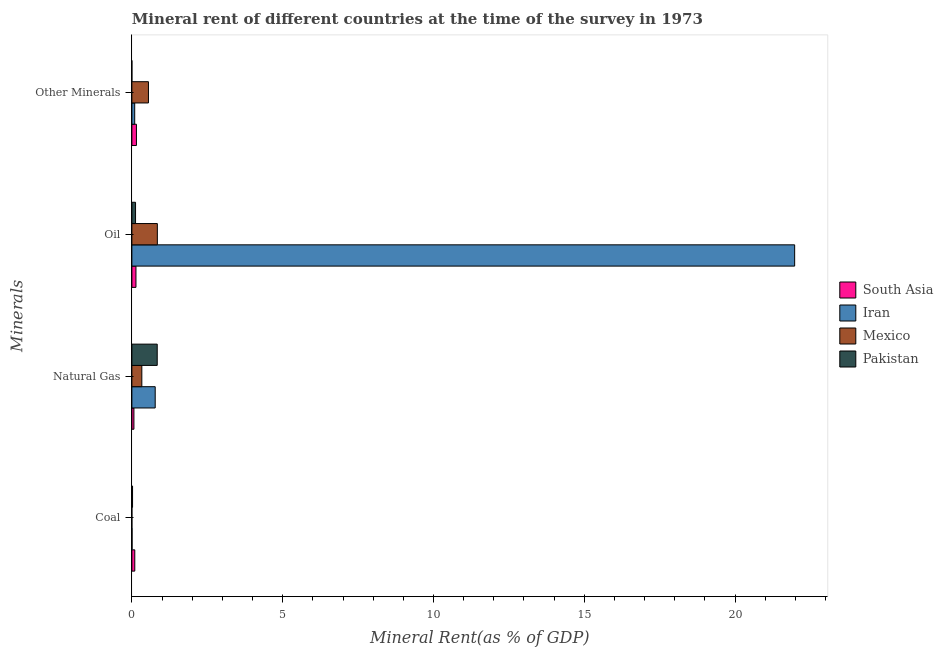How many groups of bars are there?
Your answer should be very brief. 4. Are the number of bars per tick equal to the number of legend labels?
Keep it short and to the point. Yes. Are the number of bars on each tick of the Y-axis equal?
Give a very brief answer. Yes. How many bars are there on the 2nd tick from the top?
Provide a succinct answer. 4. How many bars are there on the 2nd tick from the bottom?
Provide a succinct answer. 4. What is the label of the 4th group of bars from the top?
Provide a short and direct response. Coal. What is the oil rent in Mexico?
Offer a terse response. 0.84. Across all countries, what is the maximum  rent of other minerals?
Give a very brief answer. 0.55. Across all countries, what is the minimum  rent of other minerals?
Your response must be concise. 1.39988416425869e-5. In which country was the coal rent maximum?
Offer a terse response. South Asia. What is the total coal rent in the graph?
Provide a succinct answer. 0.13. What is the difference between the  rent of other minerals in Pakistan and that in Mexico?
Offer a very short reply. -0.55. What is the difference between the coal rent in Pakistan and the oil rent in Iran?
Give a very brief answer. -21.95. What is the average natural gas rent per country?
Keep it short and to the point. 0.5. What is the difference between the oil rent and  rent of other minerals in Mexico?
Keep it short and to the point. 0.3. In how many countries, is the  rent of other minerals greater than 21 %?
Offer a terse response. 0. What is the ratio of the oil rent in Iran to that in Pakistan?
Keep it short and to the point. 180.61. Is the difference between the natural gas rent in South Asia and Pakistan greater than the difference between the coal rent in South Asia and Pakistan?
Your response must be concise. No. What is the difference between the highest and the second highest  rent of other minerals?
Give a very brief answer. 0.4. What is the difference between the highest and the lowest  rent of other minerals?
Give a very brief answer. 0.55. In how many countries, is the natural gas rent greater than the average natural gas rent taken over all countries?
Your answer should be very brief. 2. Is it the case that in every country, the sum of the coal rent and oil rent is greater than the sum of natural gas rent and  rent of other minerals?
Your answer should be very brief. Yes. What does the 2nd bar from the top in Coal represents?
Provide a short and direct response. Mexico. What does the 1st bar from the bottom in Natural Gas represents?
Your response must be concise. South Asia. Is it the case that in every country, the sum of the coal rent and natural gas rent is greater than the oil rent?
Keep it short and to the point. No. How many bars are there?
Your answer should be very brief. 16. Are all the bars in the graph horizontal?
Your response must be concise. Yes. Are the values on the major ticks of X-axis written in scientific E-notation?
Keep it short and to the point. No. Where does the legend appear in the graph?
Your answer should be compact. Center right. How are the legend labels stacked?
Provide a succinct answer. Vertical. What is the title of the graph?
Keep it short and to the point. Mineral rent of different countries at the time of the survey in 1973. Does "Mozambique" appear as one of the legend labels in the graph?
Give a very brief answer. No. What is the label or title of the X-axis?
Keep it short and to the point. Mineral Rent(as % of GDP). What is the label or title of the Y-axis?
Keep it short and to the point. Minerals. What is the Mineral Rent(as % of GDP) of South Asia in Coal?
Make the answer very short. 0.1. What is the Mineral Rent(as % of GDP) of Iran in Coal?
Offer a very short reply. 0.01. What is the Mineral Rent(as % of GDP) of Mexico in Coal?
Keep it short and to the point. 9.86259771572145e-5. What is the Mineral Rent(as % of GDP) of Pakistan in Coal?
Give a very brief answer. 0.02. What is the Mineral Rent(as % of GDP) of South Asia in Natural Gas?
Offer a terse response. 0.07. What is the Mineral Rent(as % of GDP) of Iran in Natural Gas?
Offer a very short reply. 0.77. What is the Mineral Rent(as % of GDP) of Mexico in Natural Gas?
Your answer should be compact. 0.33. What is the Mineral Rent(as % of GDP) of Pakistan in Natural Gas?
Offer a terse response. 0.84. What is the Mineral Rent(as % of GDP) in South Asia in Oil?
Ensure brevity in your answer.  0.14. What is the Mineral Rent(as % of GDP) in Iran in Oil?
Offer a very short reply. 21.98. What is the Mineral Rent(as % of GDP) of Mexico in Oil?
Your answer should be very brief. 0.84. What is the Mineral Rent(as % of GDP) of Pakistan in Oil?
Provide a short and direct response. 0.12. What is the Mineral Rent(as % of GDP) of South Asia in Other Minerals?
Make the answer very short. 0.15. What is the Mineral Rent(as % of GDP) of Iran in Other Minerals?
Ensure brevity in your answer.  0.09. What is the Mineral Rent(as % of GDP) in Mexico in Other Minerals?
Your answer should be compact. 0.55. What is the Mineral Rent(as % of GDP) in Pakistan in Other Minerals?
Give a very brief answer. 1.39988416425869e-5. Across all Minerals, what is the maximum Mineral Rent(as % of GDP) in South Asia?
Offer a terse response. 0.15. Across all Minerals, what is the maximum Mineral Rent(as % of GDP) in Iran?
Ensure brevity in your answer.  21.98. Across all Minerals, what is the maximum Mineral Rent(as % of GDP) of Mexico?
Offer a very short reply. 0.84. Across all Minerals, what is the maximum Mineral Rent(as % of GDP) in Pakistan?
Provide a succinct answer. 0.84. Across all Minerals, what is the minimum Mineral Rent(as % of GDP) in South Asia?
Provide a short and direct response. 0.07. Across all Minerals, what is the minimum Mineral Rent(as % of GDP) of Iran?
Your answer should be very brief. 0.01. Across all Minerals, what is the minimum Mineral Rent(as % of GDP) of Mexico?
Your answer should be very brief. 9.86259771572145e-5. Across all Minerals, what is the minimum Mineral Rent(as % of GDP) in Pakistan?
Keep it short and to the point. 1.39988416425869e-5. What is the total Mineral Rent(as % of GDP) of South Asia in the graph?
Make the answer very short. 0.45. What is the total Mineral Rent(as % of GDP) of Iran in the graph?
Ensure brevity in your answer.  22.85. What is the total Mineral Rent(as % of GDP) of Mexico in the graph?
Make the answer very short. 1.72. What is the total Mineral Rent(as % of GDP) in Pakistan in the graph?
Provide a short and direct response. 0.98. What is the difference between the Mineral Rent(as % of GDP) of South Asia in Coal and that in Natural Gas?
Offer a terse response. 0.03. What is the difference between the Mineral Rent(as % of GDP) of Iran in Coal and that in Natural Gas?
Offer a terse response. -0.77. What is the difference between the Mineral Rent(as % of GDP) of Mexico in Coal and that in Natural Gas?
Your response must be concise. -0.33. What is the difference between the Mineral Rent(as % of GDP) in Pakistan in Coal and that in Natural Gas?
Keep it short and to the point. -0.82. What is the difference between the Mineral Rent(as % of GDP) in South Asia in Coal and that in Oil?
Offer a very short reply. -0.04. What is the difference between the Mineral Rent(as % of GDP) of Iran in Coal and that in Oil?
Provide a short and direct response. -21.97. What is the difference between the Mineral Rent(as % of GDP) of Mexico in Coal and that in Oil?
Provide a short and direct response. -0.84. What is the difference between the Mineral Rent(as % of GDP) in Pakistan in Coal and that in Oil?
Your answer should be very brief. -0.1. What is the difference between the Mineral Rent(as % of GDP) in South Asia in Coal and that in Other Minerals?
Give a very brief answer. -0.05. What is the difference between the Mineral Rent(as % of GDP) of Iran in Coal and that in Other Minerals?
Make the answer very short. -0.09. What is the difference between the Mineral Rent(as % of GDP) of Mexico in Coal and that in Other Minerals?
Your response must be concise. -0.55. What is the difference between the Mineral Rent(as % of GDP) of Pakistan in Coal and that in Other Minerals?
Provide a short and direct response. 0.02. What is the difference between the Mineral Rent(as % of GDP) of South Asia in Natural Gas and that in Oil?
Give a very brief answer. -0.07. What is the difference between the Mineral Rent(as % of GDP) of Iran in Natural Gas and that in Oil?
Offer a very short reply. -21.2. What is the difference between the Mineral Rent(as % of GDP) of Mexico in Natural Gas and that in Oil?
Provide a short and direct response. -0.51. What is the difference between the Mineral Rent(as % of GDP) of Pakistan in Natural Gas and that in Oil?
Give a very brief answer. 0.72. What is the difference between the Mineral Rent(as % of GDP) in South Asia in Natural Gas and that in Other Minerals?
Provide a succinct answer. -0.08. What is the difference between the Mineral Rent(as % of GDP) of Iran in Natural Gas and that in Other Minerals?
Keep it short and to the point. 0.68. What is the difference between the Mineral Rent(as % of GDP) of Mexico in Natural Gas and that in Other Minerals?
Make the answer very short. -0.22. What is the difference between the Mineral Rent(as % of GDP) in Pakistan in Natural Gas and that in Other Minerals?
Ensure brevity in your answer.  0.84. What is the difference between the Mineral Rent(as % of GDP) in South Asia in Oil and that in Other Minerals?
Give a very brief answer. -0.02. What is the difference between the Mineral Rent(as % of GDP) in Iran in Oil and that in Other Minerals?
Offer a terse response. 21.88. What is the difference between the Mineral Rent(as % of GDP) in Mexico in Oil and that in Other Minerals?
Your response must be concise. 0.3. What is the difference between the Mineral Rent(as % of GDP) in Pakistan in Oil and that in Other Minerals?
Keep it short and to the point. 0.12. What is the difference between the Mineral Rent(as % of GDP) in South Asia in Coal and the Mineral Rent(as % of GDP) in Iran in Natural Gas?
Your answer should be very brief. -0.68. What is the difference between the Mineral Rent(as % of GDP) of South Asia in Coal and the Mineral Rent(as % of GDP) of Mexico in Natural Gas?
Your answer should be very brief. -0.23. What is the difference between the Mineral Rent(as % of GDP) in South Asia in Coal and the Mineral Rent(as % of GDP) in Pakistan in Natural Gas?
Keep it short and to the point. -0.74. What is the difference between the Mineral Rent(as % of GDP) of Iran in Coal and the Mineral Rent(as % of GDP) of Mexico in Natural Gas?
Make the answer very short. -0.32. What is the difference between the Mineral Rent(as % of GDP) of Iran in Coal and the Mineral Rent(as % of GDP) of Pakistan in Natural Gas?
Offer a very short reply. -0.83. What is the difference between the Mineral Rent(as % of GDP) of Mexico in Coal and the Mineral Rent(as % of GDP) of Pakistan in Natural Gas?
Provide a short and direct response. -0.84. What is the difference between the Mineral Rent(as % of GDP) in South Asia in Coal and the Mineral Rent(as % of GDP) in Iran in Oil?
Offer a very short reply. -21.88. What is the difference between the Mineral Rent(as % of GDP) in South Asia in Coal and the Mineral Rent(as % of GDP) in Mexico in Oil?
Make the answer very short. -0.75. What is the difference between the Mineral Rent(as % of GDP) in South Asia in Coal and the Mineral Rent(as % of GDP) in Pakistan in Oil?
Your answer should be very brief. -0.03. What is the difference between the Mineral Rent(as % of GDP) of Iran in Coal and the Mineral Rent(as % of GDP) of Mexico in Oil?
Offer a terse response. -0.84. What is the difference between the Mineral Rent(as % of GDP) in Iran in Coal and the Mineral Rent(as % of GDP) in Pakistan in Oil?
Provide a short and direct response. -0.12. What is the difference between the Mineral Rent(as % of GDP) of Mexico in Coal and the Mineral Rent(as % of GDP) of Pakistan in Oil?
Your answer should be very brief. -0.12. What is the difference between the Mineral Rent(as % of GDP) in South Asia in Coal and the Mineral Rent(as % of GDP) in Iran in Other Minerals?
Your answer should be very brief. 0. What is the difference between the Mineral Rent(as % of GDP) of South Asia in Coal and the Mineral Rent(as % of GDP) of Mexico in Other Minerals?
Your answer should be compact. -0.45. What is the difference between the Mineral Rent(as % of GDP) of South Asia in Coal and the Mineral Rent(as % of GDP) of Pakistan in Other Minerals?
Your response must be concise. 0.1. What is the difference between the Mineral Rent(as % of GDP) of Iran in Coal and the Mineral Rent(as % of GDP) of Mexico in Other Minerals?
Provide a succinct answer. -0.54. What is the difference between the Mineral Rent(as % of GDP) in Iran in Coal and the Mineral Rent(as % of GDP) in Pakistan in Other Minerals?
Your response must be concise. 0.01. What is the difference between the Mineral Rent(as % of GDP) in Mexico in Coal and the Mineral Rent(as % of GDP) in Pakistan in Other Minerals?
Offer a very short reply. 0. What is the difference between the Mineral Rent(as % of GDP) of South Asia in Natural Gas and the Mineral Rent(as % of GDP) of Iran in Oil?
Offer a very short reply. -21.91. What is the difference between the Mineral Rent(as % of GDP) of South Asia in Natural Gas and the Mineral Rent(as % of GDP) of Mexico in Oil?
Provide a short and direct response. -0.78. What is the difference between the Mineral Rent(as % of GDP) of South Asia in Natural Gas and the Mineral Rent(as % of GDP) of Pakistan in Oil?
Provide a succinct answer. -0.05. What is the difference between the Mineral Rent(as % of GDP) of Iran in Natural Gas and the Mineral Rent(as % of GDP) of Mexico in Oil?
Make the answer very short. -0.07. What is the difference between the Mineral Rent(as % of GDP) in Iran in Natural Gas and the Mineral Rent(as % of GDP) in Pakistan in Oil?
Give a very brief answer. 0.65. What is the difference between the Mineral Rent(as % of GDP) in Mexico in Natural Gas and the Mineral Rent(as % of GDP) in Pakistan in Oil?
Offer a very short reply. 0.21. What is the difference between the Mineral Rent(as % of GDP) in South Asia in Natural Gas and the Mineral Rent(as % of GDP) in Iran in Other Minerals?
Make the answer very short. -0.03. What is the difference between the Mineral Rent(as % of GDP) in South Asia in Natural Gas and the Mineral Rent(as % of GDP) in Mexico in Other Minerals?
Provide a succinct answer. -0.48. What is the difference between the Mineral Rent(as % of GDP) of South Asia in Natural Gas and the Mineral Rent(as % of GDP) of Pakistan in Other Minerals?
Make the answer very short. 0.07. What is the difference between the Mineral Rent(as % of GDP) in Iran in Natural Gas and the Mineral Rent(as % of GDP) in Mexico in Other Minerals?
Ensure brevity in your answer.  0.22. What is the difference between the Mineral Rent(as % of GDP) of Iran in Natural Gas and the Mineral Rent(as % of GDP) of Pakistan in Other Minerals?
Make the answer very short. 0.77. What is the difference between the Mineral Rent(as % of GDP) of Mexico in Natural Gas and the Mineral Rent(as % of GDP) of Pakistan in Other Minerals?
Provide a succinct answer. 0.33. What is the difference between the Mineral Rent(as % of GDP) in South Asia in Oil and the Mineral Rent(as % of GDP) in Iran in Other Minerals?
Your answer should be very brief. 0.04. What is the difference between the Mineral Rent(as % of GDP) of South Asia in Oil and the Mineral Rent(as % of GDP) of Mexico in Other Minerals?
Ensure brevity in your answer.  -0.41. What is the difference between the Mineral Rent(as % of GDP) of South Asia in Oil and the Mineral Rent(as % of GDP) of Pakistan in Other Minerals?
Provide a succinct answer. 0.14. What is the difference between the Mineral Rent(as % of GDP) of Iran in Oil and the Mineral Rent(as % of GDP) of Mexico in Other Minerals?
Keep it short and to the point. 21.43. What is the difference between the Mineral Rent(as % of GDP) in Iran in Oil and the Mineral Rent(as % of GDP) in Pakistan in Other Minerals?
Your answer should be compact. 21.98. What is the difference between the Mineral Rent(as % of GDP) of Mexico in Oil and the Mineral Rent(as % of GDP) of Pakistan in Other Minerals?
Your answer should be very brief. 0.84. What is the average Mineral Rent(as % of GDP) of South Asia per Minerals?
Ensure brevity in your answer.  0.11. What is the average Mineral Rent(as % of GDP) of Iran per Minerals?
Make the answer very short. 5.71. What is the average Mineral Rent(as % of GDP) in Mexico per Minerals?
Ensure brevity in your answer.  0.43. What is the average Mineral Rent(as % of GDP) of Pakistan per Minerals?
Your answer should be compact. 0.25. What is the difference between the Mineral Rent(as % of GDP) of South Asia and Mineral Rent(as % of GDP) of Iran in Coal?
Ensure brevity in your answer.  0.09. What is the difference between the Mineral Rent(as % of GDP) in South Asia and Mineral Rent(as % of GDP) in Mexico in Coal?
Provide a short and direct response. 0.1. What is the difference between the Mineral Rent(as % of GDP) in South Asia and Mineral Rent(as % of GDP) in Pakistan in Coal?
Your response must be concise. 0.07. What is the difference between the Mineral Rent(as % of GDP) in Iran and Mineral Rent(as % of GDP) in Mexico in Coal?
Your answer should be compact. 0.01. What is the difference between the Mineral Rent(as % of GDP) of Iran and Mineral Rent(as % of GDP) of Pakistan in Coal?
Your answer should be compact. -0.02. What is the difference between the Mineral Rent(as % of GDP) in Mexico and Mineral Rent(as % of GDP) in Pakistan in Coal?
Keep it short and to the point. -0.02. What is the difference between the Mineral Rent(as % of GDP) in South Asia and Mineral Rent(as % of GDP) in Iran in Natural Gas?
Your answer should be compact. -0.71. What is the difference between the Mineral Rent(as % of GDP) in South Asia and Mineral Rent(as % of GDP) in Mexico in Natural Gas?
Offer a very short reply. -0.26. What is the difference between the Mineral Rent(as % of GDP) in South Asia and Mineral Rent(as % of GDP) in Pakistan in Natural Gas?
Your response must be concise. -0.77. What is the difference between the Mineral Rent(as % of GDP) in Iran and Mineral Rent(as % of GDP) in Mexico in Natural Gas?
Provide a succinct answer. 0.44. What is the difference between the Mineral Rent(as % of GDP) in Iran and Mineral Rent(as % of GDP) in Pakistan in Natural Gas?
Ensure brevity in your answer.  -0.07. What is the difference between the Mineral Rent(as % of GDP) in Mexico and Mineral Rent(as % of GDP) in Pakistan in Natural Gas?
Your response must be concise. -0.51. What is the difference between the Mineral Rent(as % of GDP) in South Asia and Mineral Rent(as % of GDP) in Iran in Oil?
Your answer should be compact. -21.84. What is the difference between the Mineral Rent(as % of GDP) of South Asia and Mineral Rent(as % of GDP) of Mexico in Oil?
Provide a succinct answer. -0.71. What is the difference between the Mineral Rent(as % of GDP) of South Asia and Mineral Rent(as % of GDP) of Pakistan in Oil?
Keep it short and to the point. 0.01. What is the difference between the Mineral Rent(as % of GDP) of Iran and Mineral Rent(as % of GDP) of Mexico in Oil?
Your answer should be compact. 21.13. What is the difference between the Mineral Rent(as % of GDP) in Iran and Mineral Rent(as % of GDP) in Pakistan in Oil?
Keep it short and to the point. 21.85. What is the difference between the Mineral Rent(as % of GDP) in Mexico and Mineral Rent(as % of GDP) in Pakistan in Oil?
Ensure brevity in your answer.  0.72. What is the difference between the Mineral Rent(as % of GDP) of South Asia and Mineral Rent(as % of GDP) of Iran in Other Minerals?
Make the answer very short. 0.06. What is the difference between the Mineral Rent(as % of GDP) in South Asia and Mineral Rent(as % of GDP) in Mexico in Other Minerals?
Offer a very short reply. -0.4. What is the difference between the Mineral Rent(as % of GDP) in South Asia and Mineral Rent(as % of GDP) in Pakistan in Other Minerals?
Offer a very short reply. 0.15. What is the difference between the Mineral Rent(as % of GDP) in Iran and Mineral Rent(as % of GDP) in Mexico in Other Minerals?
Your answer should be very brief. -0.46. What is the difference between the Mineral Rent(as % of GDP) in Iran and Mineral Rent(as % of GDP) in Pakistan in Other Minerals?
Ensure brevity in your answer.  0.09. What is the difference between the Mineral Rent(as % of GDP) in Mexico and Mineral Rent(as % of GDP) in Pakistan in Other Minerals?
Offer a very short reply. 0.55. What is the ratio of the Mineral Rent(as % of GDP) of South Asia in Coal to that in Natural Gas?
Offer a very short reply. 1.42. What is the ratio of the Mineral Rent(as % of GDP) of Iran in Coal to that in Natural Gas?
Your response must be concise. 0.01. What is the ratio of the Mineral Rent(as % of GDP) of Mexico in Coal to that in Natural Gas?
Provide a succinct answer. 0. What is the ratio of the Mineral Rent(as % of GDP) in Pakistan in Coal to that in Natural Gas?
Your response must be concise. 0.03. What is the ratio of the Mineral Rent(as % of GDP) of South Asia in Coal to that in Oil?
Make the answer very short. 0.72. What is the ratio of the Mineral Rent(as % of GDP) of Pakistan in Coal to that in Oil?
Your answer should be very brief. 0.18. What is the ratio of the Mineral Rent(as % of GDP) in South Asia in Coal to that in Other Minerals?
Provide a succinct answer. 0.64. What is the ratio of the Mineral Rent(as % of GDP) in Iran in Coal to that in Other Minerals?
Your answer should be very brief. 0.06. What is the ratio of the Mineral Rent(as % of GDP) in Pakistan in Coal to that in Other Minerals?
Ensure brevity in your answer.  1595.04. What is the ratio of the Mineral Rent(as % of GDP) in South Asia in Natural Gas to that in Oil?
Provide a short and direct response. 0.5. What is the ratio of the Mineral Rent(as % of GDP) of Iran in Natural Gas to that in Oil?
Offer a terse response. 0.04. What is the ratio of the Mineral Rent(as % of GDP) in Mexico in Natural Gas to that in Oil?
Make the answer very short. 0.39. What is the ratio of the Mineral Rent(as % of GDP) in Pakistan in Natural Gas to that in Oil?
Ensure brevity in your answer.  6.91. What is the ratio of the Mineral Rent(as % of GDP) in South Asia in Natural Gas to that in Other Minerals?
Your answer should be compact. 0.45. What is the ratio of the Mineral Rent(as % of GDP) in Iran in Natural Gas to that in Other Minerals?
Make the answer very short. 8.24. What is the ratio of the Mineral Rent(as % of GDP) of Mexico in Natural Gas to that in Other Minerals?
Provide a succinct answer. 0.6. What is the ratio of the Mineral Rent(as % of GDP) of Pakistan in Natural Gas to that in Other Minerals?
Provide a short and direct response. 6.00e+04. What is the ratio of the Mineral Rent(as % of GDP) in South Asia in Oil to that in Other Minerals?
Your answer should be very brief. 0.89. What is the ratio of the Mineral Rent(as % of GDP) in Iran in Oil to that in Other Minerals?
Give a very brief answer. 234.05. What is the ratio of the Mineral Rent(as % of GDP) in Mexico in Oil to that in Other Minerals?
Offer a terse response. 1.54. What is the ratio of the Mineral Rent(as % of GDP) of Pakistan in Oil to that in Other Minerals?
Give a very brief answer. 8691.5. What is the difference between the highest and the second highest Mineral Rent(as % of GDP) of South Asia?
Ensure brevity in your answer.  0.02. What is the difference between the highest and the second highest Mineral Rent(as % of GDP) in Iran?
Your response must be concise. 21.2. What is the difference between the highest and the second highest Mineral Rent(as % of GDP) of Mexico?
Ensure brevity in your answer.  0.3. What is the difference between the highest and the second highest Mineral Rent(as % of GDP) of Pakistan?
Offer a very short reply. 0.72. What is the difference between the highest and the lowest Mineral Rent(as % of GDP) of South Asia?
Ensure brevity in your answer.  0.08. What is the difference between the highest and the lowest Mineral Rent(as % of GDP) of Iran?
Offer a terse response. 21.97. What is the difference between the highest and the lowest Mineral Rent(as % of GDP) of Mexico?
Give a very brief answer. 0.84. What is the difference between the highest and the lowest Mineral Rent(as % of GDP) in Pakistan?
Give a very brief answer. 0.84. 